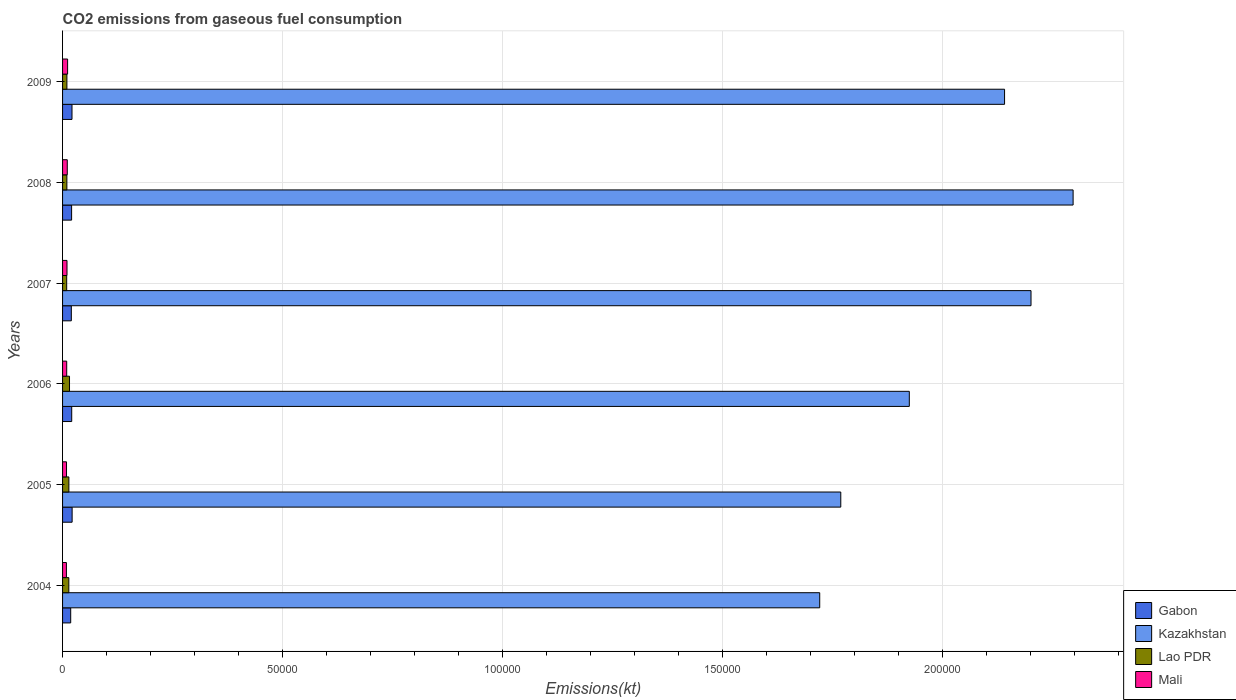How many groups of bars are there?
Provide a succinct answer. 6. Are the number of bars per tick equal to the number of legend labels?
Ensure brevity in your answer.  Yes. Are the number of bars on each tick of the Y-axis equal?
Offer a very short reply. Yes. How many bars are there on the 4th tick from the top?
Offer a very short reply. 4. What is the label of the 1st group of bars from the top?
Your answer should be compact. 2009. In how many cases, is the number of bars for a given year not equal to the number of legend labels?
Your answer should be very brief. 0. What is the amount of CO2 emitted in Mali in 2006?
Your answer should be compact. 942.42. Across all years, what is the maximum amount of CO2 emitted in Gabon?
Offer a very short reply. 2174.53. Across all years, what is the minimum amount of CO2 emitted in Lao PDR?
Your answer should be compact. 938.75. In which year was the amount of CO2 emitted in Kazakhstan minimum?
Your answer should be compact. 2004. What is the total amount of CO2 emitted in Gabon in the graph?
Keep it short and to the point. 1.23e+04. What is the difference between the amount of CO2 emitted in Mali in 2007 and that in 2009?
Make the answer very short. -139.35. What is the difference between the amount of CO2 emitted in Kazakhstan in 2004 and the amount of CO2 emitted in Gabon in 2005?
Keep it short and to the point. 1.70e+05. What is the average amount of CO2 emitted in Kazakhstan per year?
Ensure brevity in your answer.  2.01e+05. In the year 2008, what is the difference between the amount of CO2 emitted in Kazakhstan and amount of CO2 emitted in Lao PDR?
Keep it short and to the point. 2.29e+05. In how many years, is the amount of CO2 emitted in Kazakhstan greater than 50000 kt?
Your response must be concise. 6. What is the ratio of the amount of CO2 emitted in Gabon in 2008 to that in 2009?
Provide a short and direct response. 0.96. Is the amount of CO2 emitted in Mali in 2006 less than that in 2007?
Offer a terse response. Yes. Is the difference between the amount of CO2 emitted in Kazakhstan in 2006 and 2009 greater than the difference between the amount of CO2 emitted in Lao PDR in 2006 and 2009?
Provide a succinct answer. No. What is the difference between the highest and the second highest amount of CO2 emitted in Mali?
Make the answer very short. 77.01. What is the difference between the highest and the lowest amount of CO2 emitted in Gabon?
Your answer should be very brief. 322.7. Is the sum of the amount of CO2 emitted in Kazakhstan in 2006 and 2008 greater than the maximum amount of CO2 emitted in Mali across all years?
Your answer should be compact. Yes. What does the 4th bar from the top in 2007 represents?
Keep it short and to the point. Gabon. What does the 2nd bar from the bottom in 2009 represents?
Keep it short and to the point. Kazakhstan. Is it the case that in every year, the sum of the amount of CO2 emitted in Mali and amount of CO2 emitted in Gabon is greater than the amount of CO2 emitted in Kazakhstan?
Keep it short and to the point. No. Are all the bars in the graph horizontal?
Keep it short and to the point. Yes. What is the difference between two consecutive major ticks on the X-axis?
Make the answer very short. 5.00e+04. Are the values on the major ticks of X-axis written in scientific E-notation?
Give a very brief answer. No. Does the graph contain any zero values?
Ensure brevity in your answer.  No. How many legend labels are there?
Provide a succinct answer. 4. How are the legend labels stacked?
Your answer should be very brief. Vertical. What is the title of the graph?
Keep it short and to the point. CO2 emissions from gaseous fuel consumption. Does "Poland" appear as one of the legend labels in the graph?
Ensure brevity in your answer.  No. What is the label or title of the X-axis?
Give a very brief answer. Emissions(kt). What is the Emissions(kt) in Gabon in 2004?
Keep it short and to the point. 1851.84. What is the Emissions(kt) of Kazakhstan in 2004?
Provide a succinct answer. 1.72e+05. What is the Emissions(kt) of Lao PDR in 2004?
Give a very brief answer. 1422.8. What is the Emissions(kt) in Mali in 2004?
Keep it short and to the point. 876.41. What is the Emissions(kt) in Gabon in 2005?
Your response must be concise. 2174.53. What is the Emissions(kt) of Kazakhstan in 2005?
Your response must be concise. 1.77e+05. What is the Emissions(kt) of Lao PDR in 2005?
Your response must be concise. 1433.8. What is the Emissions(kt) in Mali in 2005?
Ensure brevity in your answer.  898.41. What is the Emissions(kt) of Gabon in 2006?
Offer a very short reply. 2082.86. What is the Emissions(kt) of Kazakhstan in 2006?
Ensure brevity in your answer.  1.93e+05. What is the Emissions(kt) of Lao PDR in 2006?
Offer a terse response. 1580.48. What is the Emissions(kt) in Mali in 2006?
Your response must be concise. 942.42. What is the Emissions(kt) in Gabon in 2007?
Offer a terse response. 1991.18. What is the Emissions(kt) in Kazakhstan in 2007?
Offer a very short reply. 2.20e+05. What is the Emissions(kt) of Lao PDR in 2007?
Ensure brevity in your answer.  938.75. What is the Emissions(kt) in Mali in 2007?
Provide a succinct answer. 1008.42. What is the Emissions(kt) of Gabon in 2008?
Your answer should be compact. 2057.19. What is the Emissions(kt) in Kazakhstan in 2008?
Offer a very short reply. 2.30e+05. What is the Emissions(kt) in Lao PDR in 2008?
Keep it short and to the point. 979.09. What is the Emissions(kt) in Mali in 2008?
Provide a short and direct response. 1070.76. What is the Emissions(kt) of Gabon in 2009?
Make the answer very short. 2145.2. What is the Emissions(kt) of Kazakhstan in 2009?
Offer a terse response. 2.14e+05. What is the Emissions(kt) of Lao PDR in 2009?
Ensure brevity in your answer.  986.42. What is the Emissions(kt) of Mali in 2009?
Ensure brevity in your answer.  1147.77. Across all years, what is the maximum Emissions(kt) in Gabon?
Provide a succinct answer. 2174.53. Across all years, what is the maximum Emissions(kt) in Kazakhstan?
Your answer should be very brief. 2.30e+05. Across all years, what is the maximum Emissions(kt) of Lao PDR?
Your response must be concise. 1580.48. Across all years, what is the maximum Emissions(kt) of Mali?
Your answer should be compact. 1147.77. Across all years, what is the minimum Emissions(kt) in Gabon?
Provide a short and direct response. 1851.84. Across all years, what is the minimum Emissions(kt) of Kazakhstan?
Give a very brief answer. 1.72e+05. Across all years, what is the minimum Emissions(kt) of Lao PDR?
Keep it short and to the point. 938.75. Across all years, what is the minimum Emissions(kt) of Mali?
Make the answer very short. 876.41. What is the total Emissions(kt) in Gabon in the graph?
Your response must be concise. 1.23e+04. What is the total Emissions(kt) of Kazakhstan in the graph?
Offer a very short reply. 1.21e+06. What is the total Emissions(kt) of Lao PDR in the graph?
Ensure brevity in your answer.  7341.33. What is the total Emissions(kt) in Mali in the graph?
Make the answer very short. 5944.21. What is the difference between the Emissions(kt) in Gabon in 2004 and that in 2005?
Your response must be concise. -322.7. What is the difference between the Emissions(kt) in Kazakhstan in 2004 and that in 2005?
Offer a very short reply. -4789.1. What is the difference between the Emissions(kt) of Lao PDR in 2004 and that in 2005?
Make the answer very short. -11. What is the difference between the Emissions(kt) of Mali in 2004 and that in 2005?
Give a very brief answer. -22. What is the difference between the Emissions(kt) of Gabon in 2004 and that in 2006?
Make the answer very short. -231.02. What is the difference between the Emissions(kt) of Kazakhstan in 2004 and that in 2006?
Make the answer very short. -2.04e+04. What is the difference between the Emissions(kt) of Lao PDR in 2004 and that in 2006?
Ensure brevity in your answer.  -157.68. What is the difference between the Emissions(kt) of Mali in 2004 and that in 2006?
Offer a terse response. -66.01. What is the difference between the Emissions(kt) of Gabon in 2004 and that in 2007?
Give a very brief answer. -139.35. What is the difference between the Emissions(kt) in Kazakhstan in 2004 and that in 2007?
Give a very brief answer. -4.80e+04. What is the difference between the Emissions(kt) of Lao PDR in 2004 and that in 2007?
Your answer should be compact. 484.04. What is the difference between the Emissions(kt) of Mali in 2004 and that in 2007?
Offer a terse response. -132.01. What is the difference between the Emissions(kt) in Gabon in 2004 and that in 2008?
Give a very brief answer. -205.35. What is the difference between the Emissions(kt) in Kazakhstan in 2004 and that in 2008?
Keep it short and to the point. -5.76e+04. What is the difference between the Emissions(kt) of Lao PDR in 2004 and that in 2008?
Give a very brief answer. 443.71. What is the difference between the Emissions(kt) of Mali in 2004 and that in 2008?
Keep it short and to the point. -194.35. What is the difference between the Emissions(kt) in Gabon in 2004 and that in 2009?
Your answer should be compact. -293.36. What is the difference between the Emissions(kt) of Kazakhstan in 2004 and that in 2009?
Offer a terse response. -4.20e+04. What is the difference between the Emissions(kt) in Lao PDR in 2004 and that in 2009?
Offer a very short reply. 436.37. What is the difference between the Emissions(kt) in Mali in 2004 and that in 2009?
Keep it short and to the point. -271.36. What is the difference between the Emissions(kt) of Gabon in 2005 and that in 2006?
Keep it short and to the point. 91.67. What is the difference between the Emissions(kt) in Kazakhstan in 2005 and that in 2006?
Make the answer very short. -1.56e+04. What is the difference between the Emissions(kt) in Lao PDR in 2005 and that in 2006?
Give a very brief answer. -146.68. What is the difference between the Emissions(kt) of Mali in 2005 and that in 2006?
Your answer should be compact. -44. What is the difference between the Emissions(kt) of Gabon in 2005 and that in 2007?
Provide a short and direct response. 183.35. What is the difference between the Emissions(kt) in Kazakhstan in 2005 and that in 2007?
Ensure brevity in your answer.  -4.33e+04. What is the difference between the Emissions(kt) of Lao PDR in 2005 and that in 2007?
Offer a very short reply. 495.05. What is the difference between the Emissions(kt) of Mali in 2005 and that in 2007?
Your answer should be compact. -110.01. What is the difference between the Emissions(kt) of Gabon in 2005 and that in 2008?
Make the answer very short. 117.34. What is the difference between the Emissions(kt) of Kazakhstan in 2005 and that in 2008?
Your answer should be compact. -5.28e+04. What is the difference between the Emissions(kt) of Lao PDR in 2005 and that in 2008?
Your answer should be compact. 454.71. What is the difference between the Emissions(kt) of Mali in 2005 and that in 2008?
Your answer should be very brief. -172.35. What is the difference between the Emissions(kt) of Gabon in 2005 and that in 2009?
Provide a short and direct response. 29.34. What is the difference between the Emissions(kt) in Kazakhstan in 2005 and that in 2009?
Offer a very short reply. -3.72e+04. What is the difference between the Emissions(kt) in Lao PDR in 2005 and that in 2009?
Offer a terse response. 447.37. What is the difference between the Emissions(kt) of Mali in 2005 and that in 2009?
Ensure brevity in your answer.  -249.36. What is the difference between the Emissions(kt) of Gabon in 2006 and that in 2007?
Provide a short and direct response. 91.67. What is the difference between the Emissions(kt) in Kazakhstan in 2006 and that in 2007?
Offer a very short reply. -2.77e+04. What is the difference between the Emissions(kt) of Lao PDR in 2006 and that in 2007?
Offer a terse response. 641.73. What is the difference between the Emissions(kt) in Mali in 2006 and that in 2007?
Keep it short and to the point. -66.01. What is the difference between the Emissions(kt) of Gabon in 2006 and that in 2008?
Your response must be concise. 25.67. What is the difference between the Emissions(kt) of Kazakhstan in 2006 and that in 2008?
Your answer should be very brief. -3.72e+04. What is the difference between the Emissions(kt) in Lao PDR in 2006 and that in 2008?
Make the answer very short. 601.39. What is the difference between the Emissions(kt) of Mali in 2006 and that in 2008?
Your answer should be very brief. -128.34. What is the difference between the Emissions(kt) in Gabon in 2006 and that in 2009?
Offer a terse response. -62.34. What is the difference between the Emissions(kt) in Kazakhstan in 2006 and that in 2009?
Offer a terse response. -2.17e+04. What is the difference between the Emissions(kt) in Lao PDR in 2006 and that in 2009?
Your answer should be very brief. 594.05. What is the difference between the Emissions(kt) in Mali in 2006 and that in 2009?
Your answer should be very brief. -205.35. What is the difference between the Emissions(kt) in Gabon in 2007 and that in 2008?
Provide a short and direct response. -66.01. What is the difference between the Emissions(kt) of Kazakhstan in 2007 and that in 2008?
Your answer should be very brief. -9570.87. What is the difference between the Emissions(kt) of Lao PDR in 2007 and that in 2008?
Make the answer very short. -40.34. What is the difference between the Emissions(kt) in Mali in 2007 and that in 2008?
Make the answer very short. -62.34. What is the difference between the Emissions(kt) in Gabon in 2007 and that in 2009?
Offer a terse response. -154.01. What is the difference between the Emissions(kt) of Kazakhstan in 2007 and that in 2009?
Ensure brevity in your answer.  6013.88. What is the difference between the Emissions(kt) of Lao PDR in 2007 and that in 2009?
Ensure brevity in your answer.  -47.67. What is the difference between the Emissions(kt) in Mali in 2007 and that in 2009?
Ensure brevity in your answer.  -139.35. What is the difference between the Emissions(kt) in Gabon in 2008 and that in 2009?
Offer a very short reply. -88.01. What is the difference between the Emissions(kt) of Kazakhstan in 2008 and that in 2009?
Your answer should be very brief. 1.56e+04. What is the difference between the Emissions(kt) in Lao PDR in 2008 and that in 2009?
Provide a short and direct response. -7.33. What is the difference between the Emissions(kt) of Mali in 2008 and that in 2009?
Keep it short and to the point. -77.01. What is the difference between the Emissions(kt) of Gabon in 2004 and the Emissions(kt) of Kazakhstan in 2005?
Offer a terse response. -1.75e+05. What is the difference between the Emissions(kt) in Gabon in 2004 and the Emissions(kt) in Lao PDR in 2005?
Your answer should be very brief. 418.04. What is the difference between the Emissions(kt) in Gabon in 2004 and the Emissions(kt) in Mali in 2005?
Your answer should be very brief. 953.42. What is the difference between the Emissions(kt) of Kazakhstan in 2004 and the Emissions(kt) of Lao PDR in 2005?
Your answer should be compact. 1.71e+05. What is the difference between the Emissions(kt) in Kazakhstan in 2004 and the Emissions(kt) in Mali in 2005?
Ensure brevity in your answer.  1.71e+05. What is the difference between the Emissions(kt) in Lao PDR in 2004 and the Emissions(kt) in Mali in 2005?
Offer a very short reply. 524.38. What is the difference between the Emissions(kt) of Gabon in 2004 and the Emissions(kt) of Kazakhstan in 2006?
Offer a terse response. -1.91e+05. What is the difference between the Emissions(kt) of Gabon in 2004 and the Emissions(kt) of Lao PDR in 2006?
Your response must be concise. 271.36. What is the difference between the Emissions(kt) in Gabon in 2004 and the Emissions(kt) in Mali in 2006?
Give a very brief answer. 909.42. What is the difference between the Emissions(kt) of Kazakhstan in 2004 and the Emissions(kt) of Lao PDR in 2006?
Ensure brevity in your answer.  1.71e+05. What is the difference between the Emissions(kt) of Kazakhstan in 2004 and the Emissions(kt) of Mali in 2006?
Provide a succinct answer. 1.71e+05. What is the difference between the Emissions(kt) in Lao PDR in 2004 and the Emissions(kt) in Mali in 2006?
Your answer should be very brief. 480.38. What is the difference between the Emissions(kt) of Gabon in 2004 and the Emissions(kt) of Kazakhstan in 2007?
Give a very brief answer. -2.18e+05. What is the difference between the Emissions(kt) in Gabon in 2004 and the Emissions(kt) in Lao PDR in 2007?
Give a very brief answer. 913.08. What is the difference between the Emissions(kt) in Gabon in 2004 and the Emissions(kt) in Mali in 2007?
Provide a short and direct response. 843.41. What is the difference between the Emissions(kt) in Kazakhstan in 2004 and the Emissions(kt) in Lao PDR in 2007?
Your response must be concise. 1.71e+05. What is the difference between the Emissions(kt) of Kazakhstan in 2004 and the Emissions(kt) of Mali in 2007?
Keep it short and to the point. 1.71e+05. What is the difference between the Emissions(kt) of Lao PDR in 2004 and the Emissions(kt) of Mali in 2007?
Offer a terse response. 414.37. What is the difference between the Emissions(kt) of Gabon in 2004 and the Emissions(kt) of Kazakhstan in 2008?
Give a very brief answer. -2.28e+05. What is the difference between the Emissions(kt) of Gabon in 2004 and the Emissions(kt) of Lao PDR in 2008?
Your answer should be compact. 872.75. What is the difference between the Emissions(kt) of Gabon in 2004 and the Emissions(kt) of Mali in 2008?
Make the answer very short. 781.07. What is the difference between the Emissions(kt) of Kazakhstan in 2004 and the Emissions(kt) of Lao PDR in 2008?
Your answer should be compact. 1.71e+05. What is the difference between the Emissions(kt) of Kazakhstan in 2004 and the Emissions(kt) of Mali in 2008?
Your answer should be compact. 1.71e+05. What is the difference between the Emissions(kt) in Lao PDR in 2004 and the Emissions(kt) in Mali in 2008?
Make the answer very short. 352.03. What is the difference between the Emissions(kt) of Gabon in 2004 and the Emissions(kt) of Kazakhstan in 2009?
Ensure brevity in your answer.  -2.12e+05. What is the difference between the Emissions(kt) of Gabon in 2004 and the Emissions(kt) of Lao PDR in 2009?
Keep it short and to the point. 865.41. What is the difference between the Emissions(kt) in Gabon in 2004 and the Emissions(kt) in Mali in 2009?
Keep it short and to the point. 704.06. What is the difference between the Emissions(kt) in Kazakhstan in 2004 and the Emissions(kt) in Lao PDR in 2009?
Your answer should be compact. 1.71e+05. What is the difference between the Emissions(kt) of Kazakhstan in 2004 and the Emissions(kt) of Mali in 2009?
Provide a succinct answer. 1.71e+05. What is the difference between the Emissions(kt) of Lao PDR in 2004 and the Emissions(kt) of Mali in 2009?
Keep it short and to the point. 275.02. What is the difference between the Emissions(kt) in Gabon in 2005 and the Emissions(kt) in Kazakhstan in 2006?
Give a very brief answer. -1.90e+05. What is the difference between the Emissions(kt) of Gabon in 2005 and the Emissions(kt) of Lao PDR in 2006?
Ensure brevity in your answer.  594.05. What is the difference between the Emissions(kt) in Gabon in 2005 and the Emissions(kt) in Mali in 2006?
Provide a succinct answer. 1232.11. What is the difference between the Emissions(kt) of Kazakhstan in 2005 and the Emissions(kt) of Lao PDR in 2006?
Your answer should be compact. 1.75e+05. What is the difference between the Emissions(kt) in Kazakhstan in 2005 and the Emissions(kt) in Mali in 2006?
Give a very brief answer. 1.76e+05. What is the difference between the Emissions(kt) in Lao PDR in 2005 and the Emissions(kt) in Mali in 2006?
Your response must be concise. 491.38. What is the difference between the Emissions(kt) in Gabon in 2005 and the Emissions(kt) in Kazakhstan in 2007?
Provide a succinct answer. -2.18e+05. What is the difference between the Emissions(kt) in Gabon in 2005 and the Emissions(kt) in Lao PDR in 2007?
Your answer should be very brief. 1235.78. What is the difference between the Emissions(kt) in Gabon in 2005 and the Emissions(kt) in Mali in 2007?
Provide a succinct answer. 1166.11. What is the difference between the Emissions(kt) of Kazakhstan in 2005 and the Emissions(kt) of Lao PDR in 2007?
Offer a terse response. 1.76e+05. What is the difference between the Emissions(kt) in Kazakhstan in 2005 and the Emissions(kt) in Mali in 2007?
Make the answer very short. 1.76e+05. What is the difference between the Emissions(kt) of Lao PDR in 2005 and the Emissions(kt) of Mali in 2007?
Keep it short and to the point. 425.37. What is the difference between the Emissions(kt) in Gabon in 2005 and the Emissions(kt) in Kazakhstan in 2008?
Provide a succinct answer. -2.28e+05. What is the difference between the Emissions(kt) of Gabon in 2005 and the Emissions(kt) of Lao PDR in 2008?
Give a very brief answer. 1195.44. What is the difference between the Emissions(kt) in Gabon in 2005 and the Emissions(kt) in Mali in 2008?
Make the answer very short. 1103.77. What is the difference between the Emissions(kt) in Kazakhstan in 2005 and the Emissions(kt) in Lao PDR in 2008?
Make the answer very short. 1.76e+05. What is the difference between the Emissions(kt) of Kazakhstan in 2005 and the Emissions(kt) of Mali in 2008?
Your answer should be very brief. 1.76e+05. What is the difference between the Emissions(kt) of Lao PDR in 2005 and the Emissions(kt) of Mali in 2008?
Keep it short and to the point. 363.03. What is the difference between the Emissions(kt) in Gabon in 2005 and the Emissions(kt) in Kazakhstan in 2009?
Ensure brevity in your answer.  -2.12e+05. What is the difference between the Emissions(kt) in Gabon in 2005 and the Emissions(kt) in Lao PDR in 2009?
Provide a succinct answer. 1188.11. What is the difference between the Emissions(kt) in Gabon in 2005 and the Emissions(kt) in Mali in 2009?
Keep it short and to the point. 1026.76. What is the difference between the Emissions(kt) of Kazakhstan in 2005 and the Emissions(kt) of Lao PDR in 2009?
Keep it short and to the point. 1.76e+05. What is the difference between the Emissions(kt) of Kazakhstan in 2005 and the Emissions(kt) of Mali in 2009?
Give a very brief answer. 1.76e+05. What is the difference between the Emissions(kt) of Lao PDR in 2005 and the Emissions(kt) of Mali in 2009?
Your answer should be compact. 286.03. What is the difference between the Emissions(kt) of Gabon in 2006 and the Emissions(kt) of Kazakhstan in 2007?
Provide a succinct answer. -2.18e+05. What is the difference between the Emissions(kt) of Gabon in 2006 and the Emissions(kt) of Lao PDR in 2007?
Give a very brief answer. 1144.1. What is the difference between the Emissions(kt) in Gabon in 2006 and the Emissions(kt) in Mali in 2007?
Give a very brief answer. 1074.43. What is the difference between the Emissions(kt) of Kazakhstan in 2006 and the Emissions(kt) of Lao PDR in 2007?
Give a very brief answer. 1.92e+05. What is the difference between the Emissions(kt) of Kazakhstan in 2006 and the Emissions(kt) of Mali in 2007?
Your answer should be compact. 1.92e+05. What is the difference between the Emissions(kt) in Lao PDR in 2006 and the Emissions(kt) in Mali in 2007?
Provide a short and direct response. 572.05. What is the difference between the Emissions(kt) in Gabon in 2006 and the Emissions(kt) in Kazakhstan in 2008?
Keep it short and to the point. -2.28e+05. What is the difference between the Emissions(kt) in Gabon in 2006 and the Emissions(kt) in Lao PDR in 2008?
Give a very brief answer. 1103.77. What is the difference between the Emissions(kt) of Gabon in 2006 and the Emissions(kt) of Mali in 2008?
Provide a succinct answer. 1012.09. What is the difference between the Emissions(kt) in Kazakhstan in 2006 and the Emissions(kt) in Lao PDR in 2008?
Give a very brief answer. 1.92e+05. What is the difference between the Emissions(kt) of Kazakhstan in 2006 and the Emissions(kt) of Mali in 2008?
Keep it short and to the point. 1.91e+05. What is the difference between the Emissions(kt) in Lao PDR in 2006 and the Emissions(kt) in Mali in 2008?
Provide a succinct answer. 509.71. What is the difference between the Emissions(kt) in Gabon in 2006 and the Emissions(kt) in Kazakhstan in 2009?
Provide a succinct answer. -2.12e+05. What is the difference between the Emissions(kt) in Gabon in 2006 and the Emissions(kt) in Lao PDR in 2009?
Make the answer very short. 1096.43. What is the difference between the Emissions(kt) in Gabon in 2006 and the Emissions(kt) in Mali in 2009?
Provide a succinct answer. 935.09. What is the difference between the Emissions(kt) in Kazakhstan in 2006 and the Emissions(kt) in Lao PDR in 2009?
Your answer should be compact. 1.92e+05. What is the difference between the Emissions(kt) of Kazakhstan in 2006 and the Emissions(kt) of Mali in 2009?
Keep it short and to the point. 1.91e+05. What is the difference between the Emissions(kt) of Lao PDR in 2006 and the Emissions(kt) of Mali in 2009?
Make the answer very short. 432.71. What is the difference between the Emissions(kt) in Gabon in 2007 and the Emissions(kt) in Kazakhstan in 2008?
Provide a succinct answer. -2.28e+05. What is the difference between the Emissions(kt) of Gabon in 2007 and the Emissions(kt) of Lao PDR in 2008?
Offer a very short reply. 1012.09. What is the difference between the Emissions(kt) in Gabon in 2007 and the Emissions(kt) in Mali in 2008?
Your response must be concise. 920.42. What is the difference between the Emissions(kt) in Kazakhstan in 2007 and the Emissions(kt) in Lao PDR in 2008?
Keep it short and to the point. 2.19e+05. What is the difference between the Emissions(kt) of Kazakhstan in 2007 and the Emissions(kt) of Mali in 2008?
Your answer should be very brief. 2.19e+05. What is the difference between the Emissions(kt) of Lao PDR in 2007 and the Emissions(kt) of Mali in 2008?
Give a very brief answer. -132.01. What is the difference between the Emissions(kt) of Gabon in 2007 and the Emissions(kt) of Kazakhstan in 2009?
Offer a very short reply. -2.12e+05. What is the difference between the Emissions(kt) of Gabon in 2007 and the Emissions(kt) of Lao PDR in 2009?
Keep it short and to the point. 1004.76. What is the difference between the Emissions(kt) of Gabon in 2007 and the Emissions(kt) of Mali in 2009?
Provide a short and direct response. 843.41. What is the difference between the Emissions(kt) of Kazakhstan in 2007 and the Emissions(kt) of Lao PDR in 2009?
Provide a short and direct response. 2.19e+05. What is the difference between the Emissions(kt) of Kazakhstan in 2007 and the Emissions(kt) of Mali in 2009?
Your response must be concise. 2.19e+05. What is the difference between the Emissions(kt) of Lao PDR in 2007 and the Emissions(kt) of Mali in 2009?
Give a very brief answer. -209.02. What is the difference between the Emissions(kt) in Gabon in 2008 and the Emissions(kt) in Kazakhstan in 2009?
Make the answer very short. -2.12e+05. What is the difference between the Emissions(kt) of Gabon in 2008 and the Emissions(kt) of Lao PDR in 2009?
Provide a succinct answer. 1070.76. What is the difference between the Emissions(kt) of Gabon in 2008 and the Emissions(kt) of Mali in 2009?
Your response must be concise. 909.42. What is the difference between the Emissions(kt) in Kazakhstan in 2008 and the Emissions(kt) in Lao PDR in 2009?
Offer a very short reply. 2.29e+05. What is the difference between the Emissions(kt) in Kazakhstan in 2008 and the Emissions(kt) in Mali in 2009?
Your answer should be compact. 2.29e+05. What is the difference between the Emissions(kt) in Lao PDR in 2008 and the Emissions(kt) in Mali in 2009?
Your answer should be very brief. -168.68. What is the average Emissions(kt) of Gabon per year?
Offer a very short reply. 2050.46. What is the average Emissions(kt) in Kazakhstan per year?
Give a very brief answer. 2.01e+05. What is the average Emissions(kt) in Lao PDR per year?
Make the answer very short. 1223.56. What is the average Emissions(kt) of Mali per year?
Your response must be concise. 990.7. In the year 2004, what is the difference between the Emissions(kt) in Gabon and Emissions(kt) in Kazakhstan?
Make the answer very short. -1.70e+05. In the year 2004, what is the difference between the Emissions(kt) in Gabon and Emissions(kt) in Lao PDR?
Offer a terse response. 429.04. In the year 2004, what is the difference between the Emissions(kt) of Gabon and Emissions(kt) of Mali?
Provide a short and direct response. 975.42. In the year 2004, what is the difference between the Emissions(kt) of Kazakhstan and Emissions(kt) of Lao PDR?
Make the answer very short. 1.71e+05. In the year 2004, what is the difference between the Emissions(kt) of Kazakhstan and Emissions(kt) of Mali?
Make the answer very short. 1.71e+05. In the year 2004, what is the difference between the Emissions(kt) of Lao PDR and Emissions(kt) of Mali?
Offer a very short reply. 546.38. In the year 2005, what is the difference between the Emissions(kt) of Gabon and Emissions(kt) of Kazakhstan?
Make the answer very short. -1.75e+05. In the year 2005, what is the difference between the Emissions(kt) of Gabon and Emissions(kt) of Lao PDR?
Keep it short and to the point. 740.73. In the year 2005, what is the difference between the Emissions(kt) in Gabon and Emissions(kt) in Mali?
Make the answer very short. 1276.12. In the year 2005, what is the difference between the Emissions(kt) in Kazakhstan and Emissions(kt) in Lao PDR?
Ensure brevity in your answer.  1.76e+05. In the year 2005, what is the difference between the Emissions(kt) in Kazakhstan and Emissions(kt) in Mali?
Your answer should be compact. 1.76e+05. In the year 2005, what is the difference between the Emissions(kt) of Lao PDR and Emissions(kt) of Mali?
Offer a terse response. 535.38. In the year 2006, what is the difference between the Emissions(kt) in Gabon and Emissions(kt) in Kazakhstan?
Your response must be concise. -1.90e+05. In the year 2006, what is the difference between the Emissions(kt) in Gabon and Emissions(kt) in Lao PDR?
Provide a succinct answer. 502.38. In the year 2006, what is the difference between the Emissions(kt) in Gabon and Emissions(kt) in Mali?
Make the answer very short. 1140.44. In the year 2006, what is the difference between the Emissions(kt) in Kazakhstan and Emissions(kt) in Lao PDR?
Offer a very short reply. 1.91e+05. In the year 2006, what is the difference between the Emissions(kt) of Kazakhstan and Emissions(kt) of Mali?
Your response must be concise. 1.92e+05. In the year 2006, what is the difference between the Emissions(kt) in Lao PDR and Emissions(kt) in Mali?
Your response must be concise. 638.06. In the year 2007, what is the difference between the Emissions(kt) in Gabon and Emissions(kt) in Kazakhstan?
Offer a terse response. -2.18e+05. In the year 2007, what is the difference between the Emissions(kt) in Gabon and Emissions(kt) in Lao PDR?
Give a very brief answer. 1052.43. In the year 2007, what is the difference between the Emissions(kt) of Gabon and Emissions(kt) of Mali?
Your answer should be compact. 982.76. In the year 2007, what is the difference between the Emissions(kt) in Kazakhstan and Emissions(kt) in Lao PDR?
Your answer should be compact. 2.19e+05. In the year 2007, what is the difference between the Emissions(kt) in Kazakhstan and Emissions(kt) in Mali?
Your answer should be very brief. 2.19e+05. In the year 2007, what is the difference between the Emissions(kt) of Lao PDR and Emissions(kt) of Mali?
Your answer should be compact. -69.67. In the year 2008, what is the difference between the Emissions(kt) in Gabon and Emissions(kt) in Kazakhstan?
Ensure brevity in your answer.  -2.28e+05. In the year 2008, what is the difference between the Emissions(kt) in Gabon and Emissions(kt) in Lao PDR?
Ensure brevity in your answer.  1078.1. In the year 2008, what is the difference between the Emissions(kt) in Gabon and Emissions(kt) in Mali?
Offer a very short reply. 986.42. In the year 2008, what is the difference between the Emissions(kt) in Kazakhstan and Emissions(kt) in Lao PDR?
Offer a very short reply. 2.29e+05. In the year 2008, what is the difference between the Emissions(kt) of Kazakhstan and Emissions(kt) of Mali?
Your answer should be compact. 2.29e+05. In the year 2008, what is the difference between the Emissions(kt) of Lao PDR and Emissions(kt) of Mali?
Make the answer very short. -91.67. In the year 2009, what is the difference between the Emissions(kt) in Gabon and Emissions(kt) in Kazakhstan?
Ensure brevity in your answer.  -2.12e+05. In the year 2009, what is the difference between the Emissions(kt) in Gabon and Emissions(kt) in Lao PDR?
Your answer should be compact. 1158.77. In the year 2009, what is the difference between the Emissions(kt) in Gabon and Emissions(kt) in Mali?
Make the answer very short. 997.42. In the year 2009, what is the difference between the Emissions(kt) of Kazakhstan and Emissions(kt) of Lao PDR?
Provide a succinct answer. 2.13e+05. In the year 2009, what is the difference between the Emissions(kt) of Kazakhstan and Emissions(kt) of Mali?
Your answer should be very brief. 2.13e+05. In the year 2009, what is the difference between the Emissions(kt) of Lao PDR and Emissions(kt) of Mali?
Give a very brief answer. -161.35. What is the ratio of the Emissions(kt) in Gabon in 2004 to that in 2005?
Offer a very short reply. 0.85. What is the ratio of the Emissions(kt) of Kazakhstan in 2004 to that in 2005?
Your response must be concise. 0.97. What is the ratio of the Emissions(kt) in Lao PDR in 2004 to that in 2005?
Offer a terse response. 0.99. What is the ratio of the Emissions(kt) in Mali in 2004 to that in 2005?
Give a very brief answer. 0.98. What is the ratio of the Emissions(kt) of Gabon in 2004 to that in 2006?
Provide a succinct answer. 0.89. What is the ratio of the Emissions(kt) in Kazakhstan in 2004 to that in 2006?
Provide a succinct answer. 0.89. What is the ratio of the Emissions(kt) in Lao PDR in 2004 to that in 2006?
Ensure brevity in your answer.  0.9. What is the ratio of the Emissions(kt) in Mali in 2004 to that in 2006?
Offer a very short reply. 0.93. What is the ratio of the Emissions(kt) in Kazakhstan in 2004 to that in 2007?
Provide a short and direct response. 0.78. What is the ratio of the Emissions(kt) in Lao PDR in 2004 to that in 2007?
Provide a short and direct response. 1.52. What is the ratio of the Emissions(kt) of Mali in 2004 to that in 2007?
Make the answer very short. 0.87. What is the ratio of the Emissions(kt) in Gabon in 2004 to that in 2008?
Offer a terse response. 0.9. What is the ratio of the Emissions(kt) of Kazakhstan in 2004 to that in 2008?
Ensure brevity in your answer.  0.75. What is the ratio of the Emissions(kt) in Lao PDR in 2004 to that in 2008?
Your response must be concise. 1.45. What is the ratio of the Emissions(kt) in Mali in 2004 to that in 2008?
Your answer should be very brief. 0.82. What is the ratio of the Emissions(kt) of Gabon in 2004 to that in 2009?
Provide a succinct answer. 0.86. What is the ratio of the Emissions(kt) of Kazakhstan in 2004 to that in 2009?
Your answer should be compact. 0.8. What is the ratio of the Emissions(kt) in Lao PDR in 2004 to that in 2009?
Your response must be concise. 1.44. What is the ratio of the Emissions(kt) in Mali in 2004 to that in 2009?
Give a very brief answer. 0.76. What is the ratio of the Emissions(kt) in Gabon in 2005 to that in 2006?
Offer a terse response. 1.04. What is the ratio of the Emissions(kt) in Kazakhstan in 2005 to that in 2006?
Ensure brevity in your answer.  0.92. What is the ratio of the Emissions(kt) of Lao PDR in 2005 to that in 2006?
Provide a short and direct response. 0.91. What is the ratio of the Emissions(kt) of Mali in 2005 to that in 2006?
Your answer should be compact. 0.95. What is the ratio of the Emissions(kt) of Gabon in 2005 to that in 2007?
Offer a terse response. 1.09. What is the ratio of the Emissions(kt) in Kazakhstan in 2005 to that in 2007?
Your response must be concise. 0.8. What is the ratio of the Emissions(kt) in Lao PDR in 2005 to that in 2007?
Give a very brief answer. 1.53. What is the ratio of the Emissions(kt) in Mali in 2005 to that in 2007?
Make the answer very short. 0.89. What is the ratio of the Emissions(kt) in Gabon in 2005 to that in 2008?
Keep it short and to the point. 1.06. What is the ratio of the Emissions(kt) in Kazakhstan in 2005 to that in 2008?
Your answer should be very brief. 0.77. What is the ratio of the Emissions(kt) in Lao PDR in 2005 to that in 2008?
Provide a succinct answer. 1.46. What is the ratio of the Emissions(kt) in Mali in 2005 to that in 2008?
Your response must be concise. 0.84. What is the ratio of the Emissions(kt) in Gabon in 2005 to that in 2009?
Provide a short and direct response. 1.01. What is the ratio of the Emissions(kt) in Kazakhstan in 2005 to that in 2009?
Make the answer very short. 0.83. What is the ratio of the Emissions(kt) of Lao PDR in 2005 to that in 2009?
Ensure brevity in your answer.  1.45. What is the ratio of the Emissions(kt) of Mali in 2005 to that in 2009?
Ensure brevity in your answer.  0.78. What is the ratio of the Emissions(kt) in Gabon in 2006 to that in 2007?
Your answer should be compact. 1.05. What is the ratio of the Emissions(kt) of Kazakhstan in 2006 to that in 2007?
Your answer should be very brief. 0.87. What is the ratio of the Emissions(kt) in Lao PDR in 2006 to that in 2007?
Offer a terse response. 1.68. What is the ratio of the Emissions(kt) of Mali in 2006 to that in 2007?
Keep it short and to the point. 0.93. What is the ratio of the Emissions(kt) in Gabon in 2006 to that in 2008?
Give a very brief answer. 1.01. What is the ratio of the Emissions(kt) of Kazakhstan in 2006 to that in 2008?
Offer a terse response. 0.84. What is the ratio of the Emissions(kt) of Lao PDR in 2006 to that in 2008?
Provide a succinct answer. 1.61. What is the ratio of the Emissions(kt) of Mali in 2006 to that in 2008?
Your answer should be very brief. 0.88. What is the ratio of the Emissions(kt) of Gabon in 2006 to that in 2009?
Make the answer very short. 0.97. What is the ratio of the Emissions(kt) of Kazakhstan in 2006 to that in 2009?
Your answer should be compact. 0.9. What is the ratio of the Emissions(kt) of Lao PDR in 2006 to that in 2009?
Make the answer very short. 1.6. What is the ratio of the Emissions(kt) of Mali in 2006 to that in 2009?
Give a very brief answer. 0.82. What is the ratio of the Emissions(kt) in Gabon in 2007 to that in 2008?
Offer a very short reply. 0.97. What is the ratio of the Emissions(kt) of Lao PDR in 2007 to that in 2008?
Provide a succinct answer. 0.96. What is the ratio of the Emissions(kt) of Mali in 2007 to that in 2008?
Provide a short and direct response. 0.94. What is the ratio of the Emissions(kt) in Gabon in 2007 to that in 2009?
Offer a very short reply. 0.93. What is the ratio of the Emissions(kt) of Kazakhstan in 2007 to that in 2009?
Provide a succinct answer. 1.03. What is the ratio of the Emissions(kt) of Lao PDR in 2007 to that in 2009?
Offer a very short reply. 0.95. What is the ratio of the Emissions(kt) of Mali in 2007 to that in 2009?
Ensure brevity in your answer.  0.88. What is the ratio of the Emissions(kt) of Kazakhstan in 2008 to that in 2009?
Your answer should be compact. 1.07. What is the ratio of the Emissions(kt) in Lao PDR in 2008 to that in 2009?
Give a very brief answer. 0.99. What is the ratio of the Emissions(kt) of Mali in 2008 to that in 2009?
Your response must be concise. 0.93. What is the difference between the highest and the second highest Emissions(kt) in Gabon?
Ensure brevity in your answer.  29.34. What is the difference between the highest and the second highest Emissions(kt) of Kazakhstan?
Ensure brevity in your answer.  9570.87. What is the difference between the highest and the second highest Emissions(kt) in Lao PDR?
Make the answer very short. 146.68. What is the difference between the highest and the second highest Emissions(kt) in Mali?
Your answer should be very brief. 77.01. What is the difference between the highest and the lowest Emissions(kt) of Gabon?
Provide a succinct answer. 322.7. What is the difference between the highest and the lowest Emissions(kt) of Kazakhstan?
Give a very brief answer. 5.76e+04. What is the difference between the highest and the lowest Emissions(kt) in Lao PDR?
Offer a terse response. 641.73. What is the difference between the highest and the lowest Emissions(kt) of Mali?
Your answer should be very brief. 271.36. 